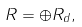Convert formula to latex. <formula><loc_0><loc_0><loc_500><loc_500>R = \oplus R _ { d } ,</formula> 